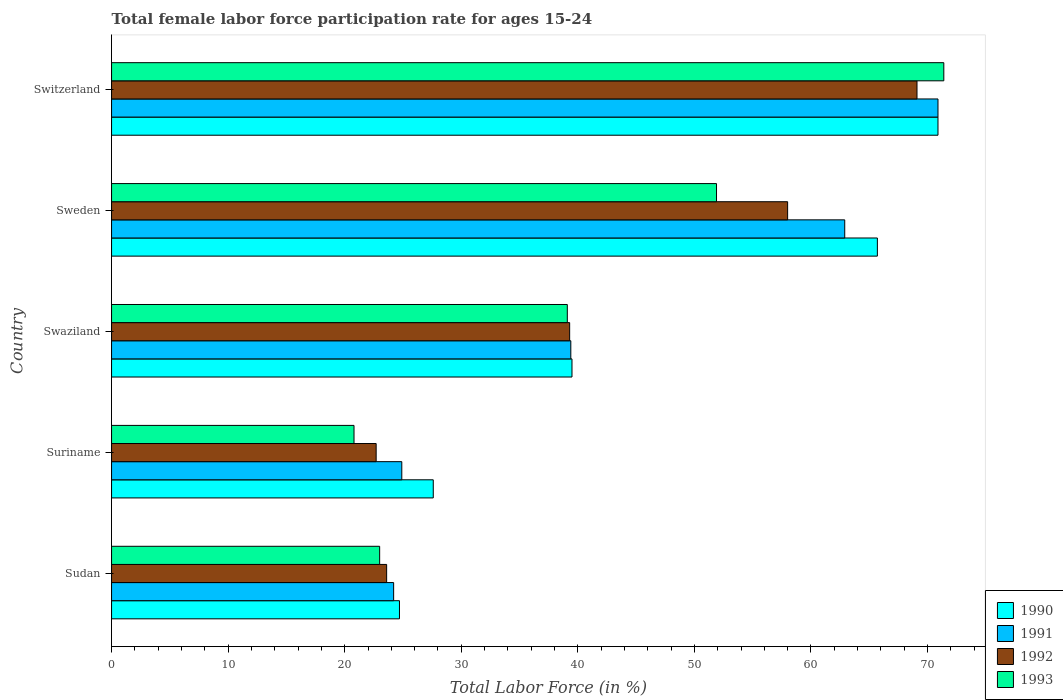How many different coloured bars are there?
Give a very brief answer. 4. Are the number of bars per tick equal to the number of legend labels?
Your response must be concise. Yes. How many bars are there on the 3rd tick from the top?
Your answer should be very brief. 4. How many bars are there on the 2nd tick from the bottom?
Your answer should be compact. 4. What is the label of the 1st group of bars from the top?
Keep it short and to the point. Switzerland. In how many cases, is the number of bars for a given country not equal to the number of legend labels?
Ensure brevity in your answer.  0. Across all countries, what is the maximum female labor force participation rate in 1991?
Make the answer very short. 70.9. Across all countries, what is the minimum female labor force participation rate in 1990?
Give a very brief answer. 24.7. In which country was the female labor force participation rate in 1993 maximum?
Your answer should be compact. Switzerland. In which country was the female labor force participation rate in 1991 minimum?
Keep it short and to the point. Sudan. What is the total female labor force participation rate in 1993 in the graph?
Keep it short and to the point. 206.2. What is the difference between the female labor force participation rate in 1991 in Sudan and that in Switzerland?
Keep it short and to the point. -46.7. What is the difference between the female labor force participation rate in 1990 in Suriname and the female labor force participation rate in 1992 in Swaziland?
Offer a very short reply. -11.7. What is the average female labor force participation rate in 1993 per country?
Ensure brevity in your answer.  41.24. What is the difference between the female labor force participation rate in 1990 and female labor force participation rate in 1993 in Sweden?
Your answer should be compact. 13.8. What is the ratio of the female labor force participation rate in 1991 in Sweden to that in Switzerland?
Ensure brevity in your answer.  0.89. Is the female labor force participation rate in 1990 in Sudan less than that in Switzerland?
Your answer should be compact. Yes. What is the difference between the highest and the second highest female labor force participation rate in 1991?
Give a very brief answer. 8. What is the difference between the highest and the lowest female labor force participation rate in 1992?
Provide a short and direct response. 46.4. In how many countries, is the female labor force participation rate in 1991 greater than the average female labor force participation rate in 1991 taken over all countries?
Your response must be concise. 2. Is the sum of the female labor force participation rate in 1991 in Sweden and Switzerland greater than the maximum female labor force participation rate in 1993 across all countries?
Provide a succinct answer. Yes. Is it the case that in every country, the sum of the female labor force participation rate in 1993 and female labor force participation rate in 1991 is greater than the female labor force participation rate in 1990?
Your response must be concise. Yes. Are all the bars in the graph horizontal?
Give a very brief answer. Yes. How many countries are there in the graph?
Your answer should be compact. 5. Are the values on the major ticks of X-axis written in scientific E-notation?
Provide a succinct answer. No. Does the graph contain grids?
Give a very brief answer. No. What is the title of the graph?
Provide a succinct answer. Total female labor force participation rate for ages 15-24. What is the label or title of the X-axis?
Ensure brevity in your answer.  Total Labor Force (in %). What is the Total Labor Force (in %) of 1990 in Sudan?
Ensure brevity in your answer.  24.7. What is the Total Labor Force (in %) of 1991 in Sudan?
Your answer should be compact. 24.2. What is the Total Labor Force (in %) in 1992 in Sudan?
Offer a terse response. 23.6. What is the Total Labor Force (in %) of 1990 in Suriname?
Offer a terse response. 27.6. What is the Total Labor Force (in %) in 1991 in Suriname?
Your answer should be compact. 24.9. What is the Total Labor Force (in %) of 1992 in Suriname?
Make the answer very short. 22.7. What is the Total Labor Force (in %) of 1993 in Suriname?
Provide a short and direct response. 20.8. What is the Total Labor Force (in %) in 1990 in Swaziland?
Your response must be concise. 39.5. What is the Total Labor Force (in %) of 1991 in Swaziland?
Offer a terse response. 39.4. What is the Total Labor Force (in %) in 1992 in Swaziland?
Make the answer very short. 39.3. What is the Total Labor Force (in %) in 1993 in Swaziland?
Ensure brevity in your answer.  39.1. What is the Total Labor Force (in %) of 1990 in Sweden?
Provide a short and direct response. 65.7. What is the Total Labor Force (in %) of 1991 in Sweden?
Provide a succinct answer. 62.9. What is the Total Labor Force (in %) in 1993 in Sweden?
Give a very brief answer. 51.9. What is the Total Labor Force (in %) of 1990 in Switzerland?
Your answer should be compact. 70.9. What is the Total Labor Force (in %) of 1991 in Switzerland?
Give a very brief answer. 70.9. What is the Total Labor Force (in %) in 1992 in Switzerland?
Your response must be concise. 69.1. What is the Total Labor Force (in %) of 1993 in Switzerland?
Your answer should be compact. 71.4. Across all countries, what is the maximum Total Labor Force (in %) in 1990?
Your answer should be very brief. 70.9. Across all countries, what is the maximum Total Labor Force (in %) of 1991?
Ensure brevity in your answer.  70.9. Across all countries, what is the maximum Total Labor Force (in %) of 1992?
Your answer should be compact. 69.1. Across all countries, what is the maximum Total Labor Force (in %) in 1993?
Your answer should be very brief. 71.4. Across all countries, what is the minimum Total Labor Force (in %) in 1990?
Your answer should be compact. 24.7. Across all countries, what is the minimum Total Labor Force (in %) of 1991?
Provide a succinct answer. 24.2. Across all countries, what is the minimum Total Labor Force (in %) in 1992?
Keep it short and to the point. 22.7. Across all countries, what is the minimum Total Labor Force (in %) of 1993?
Ensure brevity in your answer.  20.8. What is the total Total Labor Force (in %) in 1990 in the graph?
Offer a terse response. 228.4. What is the total Total Labor Force (in %) of 1991 in the graph?
Your answer should be very brief. 222.3. What is the total Total Labor Force (in %) of 1992 in the graph?
Provide a short and direct response. 212.7. What is the total Total Labor Force (in %) in 1993 in the graph?
Make the answer very short. 206.2. What is the difference between the Total Labor Force (in %) of 1990 in Sudan and that in Swaziland?
Offer a terse response. -14.8. What is the difference between the Total Labor Force (in %) of 1991 in Sudan and that in Swaziland?
Your answer should be very brief. -15.2. What is the difference between the Total Labor Force (in %) in 1992 in Sudan and that in Swaziland?
Provide a short and direct response. -15.7. What is the difference between the Total Labor Force (in %) in 1993 in Sudan and that in Swaziland?
Keep it short and to the point. -16.1. What is the difference between the Total Labor Force (in %) in 1990 in Sudan and that in Sweden?
Your answer should be compact. -41. What is the difference between the Total Labor Force (in %) in 1991 in Sudan and that in Sweden?
Ensure brevity in your answer.  -38.7. What is the difference between the Total Labor Force (in %) in 1992 in Sudan and that in Sweden?
Offer a terse response. -34.4. What is the difference between the Total Labor Force (in %) in 1993 in Sudan and that in Sweden?
Offer a terse response. -28.9. What is the difference between the Total Labor Force (in %) in 1990 in Sudan and that in Switzerland?
Your response must be concise. -46.2. What is the difference between the Total Labor Force (in %) of 1991 in Sudan and that in Switzerland?
Your answer should be very brief. -46.7. What is the difference between the Total Labor Force (in %) of 1992 in Sudan and that in Switzerland?
Your response must be concise. -45.5. What is the difference between the Total Labor Force (in %) of 1993 in Sudan and that in Switzerland?
Your answer should be compact. -48.4. What is the difference between the Total Labor Force (in %) of 1992 in Suriname and that in Swaziland?
Your answer should be very brief. -16.6. What is the difference between the Total Labor Force (in %) in 1993 in Suriname and that in Swaziland?
Provide a short and direct response. -18.3. What is the difference between the Total Labor Force (in %) in 1990 in Suriname and that in Sweden?
Offer a terse response. -38.1. What is the difference between the Total Labor Force (in %) of 1991 in Suriname and that in Sweden?
Offer a very short reply. -38. What is the difference between the Total Labor Force (in %) of 1992 in Suriname and that in Sweden?
Provide a short and direct response. -35.3. What is the difference between the Total Labor Force (in %) in 1993 in Suriname and that in Sweden?
Your response must be concise. -31.1. What is the difference between the Total Labor Force (in %) of 1990 in Suriname and that in Switzerland?
Provide a short and direct response. -43.3. What is the difference between the Total Labor Force (in %) in 1991 in Suriname and that in Switzerland?
Offer a very short reply. -46. What is the difference between the Total Labor Force (in %) in 1992 in Suriname and that in Switzerland?
Your answer should be very brief. -46.4. What is the difference between the Total Labor Force (in %) in 1993 in Suriname and that in Switzerland?
Your response must be concise. -50.6. What is the difference between the Total Labor Force (in %) in 1990 in Swaziland and that in Sweden?
Your answer should be compact. -26.2. What is the difference between the Total Labor Force (in %) in 1991 in Swaziland and that in Sweden?
Your answer should be compact. -23.5. What is the difference between the Total Labor Force (in %) of 1992 in Swaziland and that in Sweden?
Make the answer very short. -18.7. What is the difference between the Total Labor Force (in %) of 1990 in Swaziland and that in Switzerland?
Offer a very short reply. -31.4. What is the difference between the Total Labor Force (in %) in 1991 in Swaziland and that in Switzerland?
Ensure brevity in your answer.  -31.5. What is the difference between the Total Labor Force (in %) of 1992 in Swaziland and that in Switzerland?
Offer a terse response. -29.8. What is the difference between the Total Labor Force (in %) of 1993 in Swaziland and that in Switzerland?
Keep it short and to the point. -32.3. What is the difference between the Total Labor Force (in %) in 1992 in Sweden and that in Switzerland?
Your answer should be compact. -11.1. What is the difference between the Total Labor Force (in %) in 1993 in Sweden and that in Switzerland?
Offer a terse response. -19.5. What is the difference between the Total Labor Force (in %) in 1990 in Sudan and the Total Labor Force (in %) in 1992 in Suriname?
Provide a succinct answer. 2. What is the difference between the Total Labor Force (in %) in 1990 in Sudan and the Total Labor Force (in %) in 1993 in Suriname?
Give a very brief answer. 3.9. What is the difference between the Total Labor Force (in %) of 1991 in Sudan and the Total Labor Force (in %) of 1992 in Suriname?
Make the answer very short. 1.5. What is the difference between the Total Labor Force (in %) of 1990 in Sudan and the Total Labor Force (in %) of 1991 in Swaziland?
Your response must be concise. -14.7. What is the difference between the Total Labor Force (in %) of 1990 in Sudan and the Total Labor Force (in %) of 1992 in Swaziland?
Offer a very short reply. -14.6. What is the difference between the Total Labor Force (in %) of 1990 in Sudan and the Total Labor Force (in %) of 1993 in Swaziland?
Your answer should be very brief. -14.4. What is the difference between the Total Labor Force (in %) in 1991 in Sudan and the Total Labor Force (in %) in 1992 in Swaziland?
Your answer should be compact. -15.1. What is the difference between the Total Labor Force (in %) in 1991 in Sudan and the Total Labor Force (in %) in 1993 in Swaziland?
Offer a terse response. -14.9. What is the difference between the Total Labor Force (in %) of 1992 in Sudan and the Total Labor Force (in %) of 1993 in Swaziland?
Offer a terse response. -15.5. What is the difference between the Total Labor Force (in %) of 1990 in Sudan and the Total Labor Force (in %) of 1991 in Sweden?
Your answer should be compact. -38.2. What is the difference between the Total Labor Force (in %) of 1990 in Sudan and the Total Labor Force (in %) of 1992 in Sweden?
Offer a terse response. -33.3. What is the difference between the Total Labor Force (in %) of 1990 in Sudan and the Total Labor Force (in %) of 1993 in Sweden?
Ensure brevity in your answer.  -27.2. What is the difference between the Total Labor Force (in %) in 1991 in Sudan and the Total Labor Force (in %) in 1992 in Sweden?
Make the answer very short. -33.8. What is the difference between the Total Labor Force (in %) in 1991 in Sudan and the Total Labor Force (in %) in 1993 in Sweden?
Make the answer very short. -27.7. What is the difference between the Total Labor Force (in %) of 1992 in Sudan and the Total Labor Force (in %) of 1993 in Sweden?
Offer a very short reply. -28.3. What is the difference between the Total Labor Force (in %) in 1990 in Sudan and the Total Labor Force (in %) in 1991 in Switzerland?
Your answer should be very brief. -46.2. What is the difference between the Total Labor Force (in %) in 1990 in Sudan and the Total Labor Force (in %) in 1992 in Switzerland?
Offer a terse response. -44.4. What is the difference between the Total Labor Force (in %) of 1990 in Sudan and the Total Labor Force (in %) of 1993 in Switzerland?
Offer a terse response. -46.7. What is the difference between the Total Labor Force (in %) in 1991 in Sudan and the Total Labor Force (in %) in 1992 in Switzerland?
Your answer should be very brief. -44.9. What is the difference between the Total Labor Force (in %) of 1991 in Sudan and the Total Labor Force (in %) of 1993 in Switzerland?
Your answer should be very brief. -47.2. What is the difference between the Total Labor Force (in %) of 1992 in Sudan and the Total Labor Force (in %) of 1993 in Switzerland?
Your answer should be compact. -47.8. What is the difference between the Total Labor Force (in %) of 1990 in Suriname and the Total Labor Force (in %) of 1992 in Swaziland?
Give a very brief answer. -11.7. What is the difference between the Total Labor Force (in %) of 1990 in Suriname and the Total Labor Force (in %) of 1993 in Swaziland?
Provide a succinct answer. -11.5. What is the difference between the Total Labor Force (in %) in 1991 in Suriname and the Total Labor Force (in %) in 1992 in Swaziland?
Offer a very short reply. -14.4. What is the difference between the Total Labor Force (in %) in 1992 in Suriname and the Total Labor Force (in %) in 1993 in Swaziland?
Make the answer very short. -16.4. What is the difference between the Total Labor Force (in %) in 1990 in Suriname and the Total Labor Force (in %) in 1991 in Sweden?
Your answer should be very brief. -35.3. What is the difference between the Total Labor Force (in %) in 1990 in Suriname and the Total Labor Force (in %) in 1992 in Sweden?
Your answer should be compact. -30.4. What is the difference between the Total Labor Force (in %) in 1990 in Suriname and the Total Labor Force (in %) in 1993 in Sweden?
Offer a terse response. -24.3. What is the difference between the Total Labor Force (in %) in 1991 in Suriname and the Total Labor Force (in %) in 1992 in Sweden?
Your response must be concise. -33.1. What is the difference between the Total Labor Force (in %) in 1991 in Suriname and the Total Labor Force (in %) in 1993 in Sweden?
Your response must be concise. -27. What is the difference between the Total Labor Force (in %) of 1992 in Suriname and the Total Labor Force (in %) of 1993 in Sweden?
Give a very brief answer. -29.2. What is the difference between the Total Labor Force (in %) of 1990 in Suriname and the Total Labor Force (in %) of 1991 in Switzerland?
Make the answer very short. -43.3. What is the difference between the Total Labor Force (in %) in 1990 in Suriname and the Total Labor Force (in %) in 1992 in Switzerland?
Make the answer very short. -41.5. What is the difference between the Total Labor Force (in %) of 1990 in Suriname and the Total Labor Force (in %) of 1993 in Switzerland?
Give a very brief answer. -43.8. What is the difference between the Total Labor Force (in %) of 1991 in Suriname and the Total Labor Force (in %) of 1992 in Switzerland?
Offer a terse response. -44.2. What is the difference between the Total Labor Force (in %) of 1991 in Suriname and the Total Labor Force (in %) of 1993 in Switzerland?
Offer a terse response. -46.5. What is the difference between the Total Labor Force (in %) in 1992 in Suriname and the Total Labor Force (in %) in 1993 in Switzerland?
Offer a very short reply. -48.7. What is the difference between the Total Labor Force (in %) of 1990 in Swaziland and the Total Labor Force (in %) of 1991 in Sweden?
Your answer should be compact. -23.4. What is the difference between the Total Labor Force (in %) in 1990 in Swaziland and the Total Labor Force (in %) in 1992 in Sweden?
Keep it short and to the point. -18.5. What is the difference between the Total Labor Force (in %) in 1990 in Swaziland and the Total Labor Force (in %) in 1993 in Sweden?
Give a very brief answer. -12.4. What is the difference between the Total Labor Force (in %) of 1991 in Swaziland and the Total Labor Force (in %) of 1992 in Sweden?
Provide a short and direct response. -18.6. What is the difference between the Total Labor Force (in %) in 1992 in Swaziland and the Total Labor Force (in %) in 1993 in Sweden?
Provide a succinct answer. -12.6. What is the difference between the Total Labor Force (in %) in 1990 in Swaziland and the Total Labor Force (in %) in 1991 in Switzerland?
Your answer should be compact. -31.4. What is the difference between the Total Labor Force (in %) of 1990 in Swaziland and the Total Labor Force (in %) of 1992 in Switzerland?
Provide a succinct answer. -29.6. What is the difference between the Total Labor Force (in %) of 1990 in Swaziland and the Total Labor Force (in %) of 1993 in Switzerland?
Offer a very short reply. -31.9. What is the difference between the Total Labor Force (in %) in 1991 in Swaziland and the Total Labor Force (in %) in 1992 in Switzerland?
Your response must be concise. -29.7. What is the difference between the Total Labor Force (in %) in 1991 in Swaziland and the Total Labor Force (in %) in 1993 in Switzerland?
Your response must be concise. -32. What is the difference between the Total Labor Force (in %) in 1992 in Swaziland and the Total Labor Force (in %) in 1993 in Switzerland?
Give a very brief answer. -32.1. What is the difference between the Total Labor Force (in %) of 1990 in Sweden and the Total Labor Force (in %) of 1993 in Switzerland?
Your answer should be compact. -5.7. What is the difference between the Total Labor Force (in %) in 1991 in Sweden and the Total Labor Force (in %) in 1992 in Switzerland?
Offer a very short reply. -6.2. What is the difference between the Total Labor Force (in %) in 1991 in Sweden and the Total Labor Force (in %) in 1993 in Switzerland?
Your answer should be compact. -8.5. What is the average Total Labor Force (in %) in 1990 per country?
Provide a succinct answer. 45.68. What is the average Total Labor Force (in %) of 1991 per country?
Ensure brevity in your answer.  44.46. What is the average Total Labor Force (in %) of 1992 per country?
Make the answer very short. 42.54. What is the average Total Labor Force (in %) of 1993 per country?
Keep it short and to the point. 41.24. What is the difference between the Total Labor Force (in %) in 1990 and Total Labor Force (in %) in 1991 in Sudan?
Give a very brief answer. 0.5. What is the difference between the Total Labor Force (in %) in 1990 and Total Labor Force (in %) in 1992 in Sudan?
Offer a terse response. 1.1. What is the difference between the Total Labor Force (in %) in 1991 and Total Labor Force (in %) in 1992 in Sudan?
Make the answer very short. 0.6. What is the difference between the Total Labor Force (in %) in 1991 and Total Labor Force (in %) in 1993 in Sudan?
Your answer should be very brief. 1.2. What is the difference between the Total Labor Force (in %) in 1990 and Total Labor Force (in %) in 1991 in Suriname?
Your response must be concise. 2.7. What is the difference between the Total Labor Force (in %) in 1990 and Total Labor Force (in %) in 1992 in Suriname?
Provide a succinct answer. 4.9. What is the difference between the Total Labor Force (in %) in 1991 and Total Labor Force (in %) in 1992 in Suriname?
Offer a terse response. 2.2. What is the difference between the Total Labor Force (in %) in 1991 and Total Labor Force (in %) in 1993 in Suriname?
Offer a terse response. 4.1. What is the difference between the Total Labor Force (in %) of 1990 and Total Labor Force (in %) of 1992 in Swaziland?
Ensure brevity in your answer.  0.2. What is the difference between the Total Labor Force (in %) of 1991 and Total Labor Force (in %) of 1993 in Swaziland?
Offer a very short reply. 0.3. What is the difference between the Total Labor Force (in %) of 1992 and Total Labor Force (in %) of 1993 in Swaziland?
Offer a terse response. 0.2. What is the difference between the Total Labor Force (in %) of 1990 and Total Labor Force (in %) of 1991 in Sweden?
Make the answer very short. 2.8. What is the difference between the Total Labor Force (in %) of 1991 and Total Labor Force (in %) of 1992 in Sweden?
Ensure brevity in your answer.  4.9. What is the difference between the Total Labor Force (in %) of 1992 and Total Labor Force (in %) of 1993 in Sweden?
Ensure brevity in your answer.  6.1. What is the difference between the Total Labor Force (in %) in 1990 and Total Labor Force (in %) in 1991 in Switzerland?
Provide a succinct answer. 0. What is the difference between the Total Labor Force (in %) in 1990 and Total Labor Force (in %) in 1992 in Switzerland?
Offer a terse response. 1.8. What is the difference between the Total Labor Force (in %) of 1991 and Total Labor Force (in %) of 1992 in Switzerland?
Offer a very short reply. 1.8. What is the difference between the Total Labor Force (in %) of 1991 and Total Labor Force (in %) of 1993 in Switzerland?
Provide a short and direct response. -0.5. What is the difference between the Total Labor Force (in %) in 1992 and Total Labor Force (in %) in 1993 in Switzerland?
Your answer should be compact. -2.3. What is the ratio of the Total Labor Force (in %) in 1990 in Sudan to that in Suriname?
Your answer should be compact. 0.89. What is the ratio of the Total Labor Force (in %) of 1991 in Sudan to that in Suriname?
Offer a very short reply. 0.97. What is the ratio of the Total Labor Force (in %) of 1992 in Sudan to that in Suriname?
Keep it short and to the point. 1.04. What is the ratio of the Total Labor Force (in %) of 1993 in Sudan to that in Suriname?
Your response must be concise. 1.11. What is the ratio of the Total Labor Force (in %) in 1990 in Sudan to that in Swaziland?
Offer a very short reply. 0.63. What is the ratio of the Total Labor Force (in %) of 1991 in Sudan to that in Swaziland?
Offer a very short reply. 0.61. What is the ratio of the Total Labor Force (in %) of 1992 in Sudan to that in Swaziland?
Provide a short and direct response. 0.6. What is the ratio of the Total Labor Force (in %) in 1993 in Sudan to that in Swaziland?
Provide a succinct answer. 0.59. What is the ratio of the Total Labor Force (in %) of 1990 in Sudan to that in Sweden?
Provide a succinct answer. 0.38. What is the ratio of the Total Labor Force (in %) in 1991 in Sudan to that in Sweden?
Your response must be concise. 0.38. What is the ratio of the Total Labor Force (in %) in 1992 in Sudan to that in Sweden?
Keep it short and to the point. 0.41. What is the ratio of the Total Labor Force (in %) of 1993 in Sudan to that in Sweden?
Provide a succinct answer. 0.44. What is the ratio of the Total Labor Force (in %) of 1990 in Sudan to that in Switzerland?
Provide a succinct answer. 0.35. What is the ratio of the Total Labor Force (in %) of 1991 in Sudan to that in Switzerland?
Offer a very short reply. 0.34. What is the ratio of the Total Labor Force (in %) in 1992 in Sudan to that in Switzerland?
Your answer should be very brief. 0.34. What is the ratio of the Total Labor Force (in %) of 1993 in Sudan to that in Switzerland?
Make the answer very short. 0.32. What is the ratio of the Total Labor Force (in %) of 1990 in Suriname to that in Swaziland?
Your response must be concise. 0.7. What is the ratio of the Total Labor Force (in %) of 1991 in Suriname to that in Swaziland?
Your response must be concise. 0.63. What is the ratio of the Total Labor Force (in %) in 1992 in Suriname to that in Swaziland?
Make the answer very short. 0.58. What is the ratio of the Total Labor Force (in %) in 1993 in Suriname to that in Swaziland?
Your answer should be very brief. 0.53. What is the ratio of the Total Labor Force (in %) in 1990 in Suriname to that in Sweden?
Offer a terse response. 0.42. What is the ratio of the Total Labor Force (in %) in 1991 in Suriname to that in Sweden?
Your response must be concise. 0.4. What is the ratio of the Total Labor Force (in %) in 1992 in Suriname to that in Sweden?
Make the answer very short. 0.39. What is the ratio of the Total Labor Force (in %) of 1993 in Suriname to that in Sweden?
Keep it short and to the point. 0.4. What is the ratio of the Total Labor Force (in %) in 1990 in Suriname to that in Switzerland?
Your answer should be very brief. 0.39. What is the ratio of the Total Labor Force (in %) of 1991 in Suriname to that in Switzerland?
Provide a short and direct response. 0.35. What is the ratio of the Total Labor Force (in %) of 1992 in Suriname to that in Switzerland?
Provide a succinct answer. 0.33. What is the ratio of the Total Labor Force (in %) in 1993 in Suriname to that in Switzerland?
Offer a terse response. 0.29. What is the ratio of the Total Labor Force (in %) of 1990 in Swaziland to that in Sweden?
Provide a succinct answer. 0.6. What is the ratio of the Total Labor Force (in %) of 1991 in Swaziland to that in Sweden?
Your answer should be very brief. 0.63. What is the ratio of the Total Labor Force (in %) in 1992 in Swaziland to that in Sweden?
Give a very brief answer. 0.68. What is the ratio of the Total Labor Force (in %) of 1993 in Swaziland to that in Sweden?
Keep it short and to the point. 0.75. What is the ratio of the Total Labor Force (in %) of 1990 in Swaziland to that in Switzerland?
Your answer should be compact. 0.56. What is the ratio of the Total Labor Force (in %) in 1991 in Swaziland to that in Switzerland?
Provide a succinct answer. 0.56. What is the ratio of the Total Labor Force (in %) of 1992 in Swaziland to that in Switzerland?
Offer a very short reply. 0.57. What is the ratio of the Total Labor Force (in %) of 1993 in Swaziland to that in Switzerland?
Provide a succinct answer. 0.55. What is the ratio of the Total Labor Force (in %) in 1990 in Sweden to that in Switzerland?
Make the answer very short. 0.93. What is the ratio of the Total Labor Force (in %) in 1991 in Sweden to that in Switzerland?
Your response must be concise. 0.89. What is the ratio of the Total Labor Force (in %) of 1992 in Sweden to that in Switzerland?
Provide a succinct answer. 0.84. What is the ratio of the Total Labor Force (in %) of 1993 in Sweden to that in Switzerland?
Make the answer very short. 0.73. What is the difference between the highest and the second highest Total Labor Force (in %) in 1992?
Offer a very short reply. 11.1. What is the difference between the highest and the second highest Total Labor Force (in %) of 1993?
Offer a very short reply. 19.5. What is the difference between the highest and the lowest Total Labor Force (in %) of 1990?
Keep it short and to the point. 46.2. What is the difference between the highest and the lowest Total Labor Force (in %) of 1991?
Offer a terse response. 46.7. What is the difference between the highest and the lowest Total Labor Force (in %) of 1992?
Make the answer very short. 46.4. What is the difference between the highest and the lowest Total Labor Force (in %) of 1993?
Your answer should be compact. 50.6. 